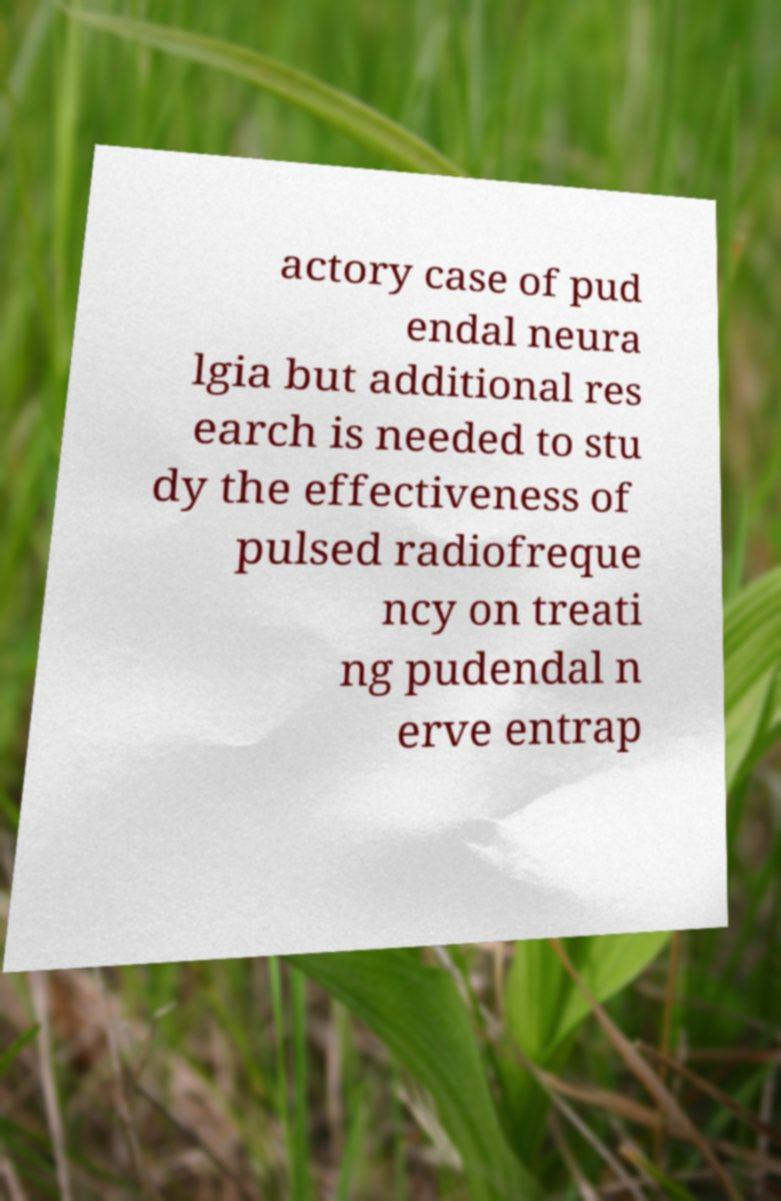For documentation purposes, I need the text within this image transcribed. Could you provide that? actory case of pud endal neura lgia but additional res earch is needed to stu dy the effectiveness of pulsed radiofreque ncy on treati ng pudendal n erve entrap 